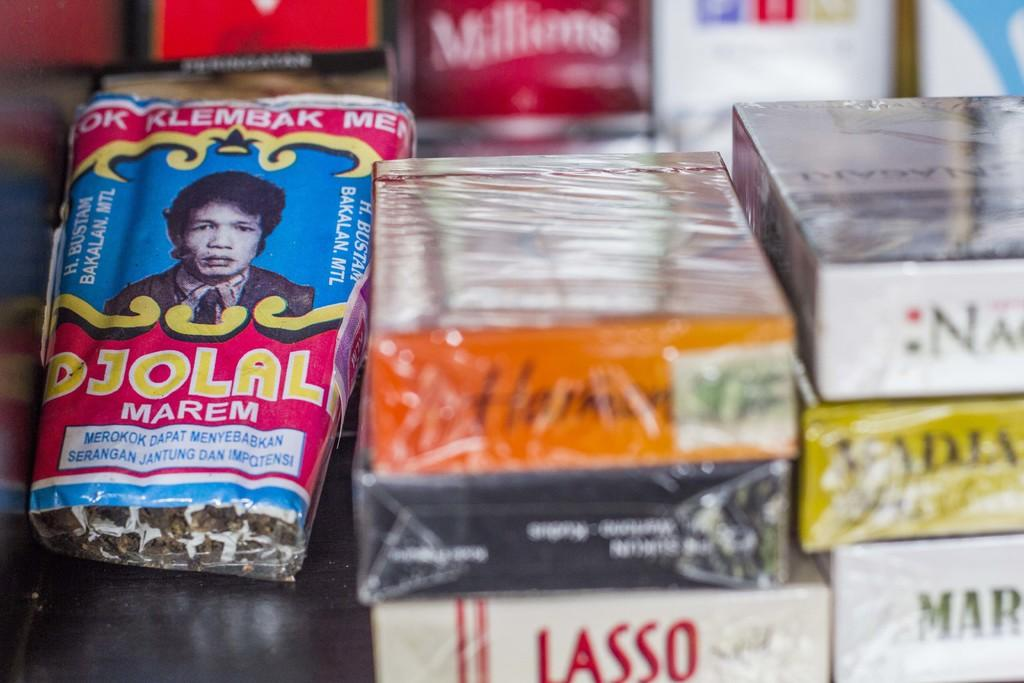What objects can be seen in the image? There are boxes and packets in the image. Where are the packets located in the image? The packets are on the left side of the image. What additional detail can be observed in the image? There is a sticker in the image. Is there any representation of a person in the image? Yes, there is a human image in the image. How would you describe the background of the image? The background of the image has a blurred view. What type of nut is being used to open the drawer in the image? There is no drawer or nut present in the image. What drink is being poured by the person in the image? There is no person or drink present in the image. 